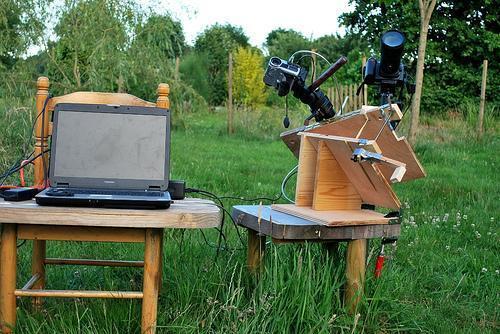How many electronic items are pictured?
Give a very brief answer. 3. How many chairs are in the photo?
Give a very brief answer. 2. 